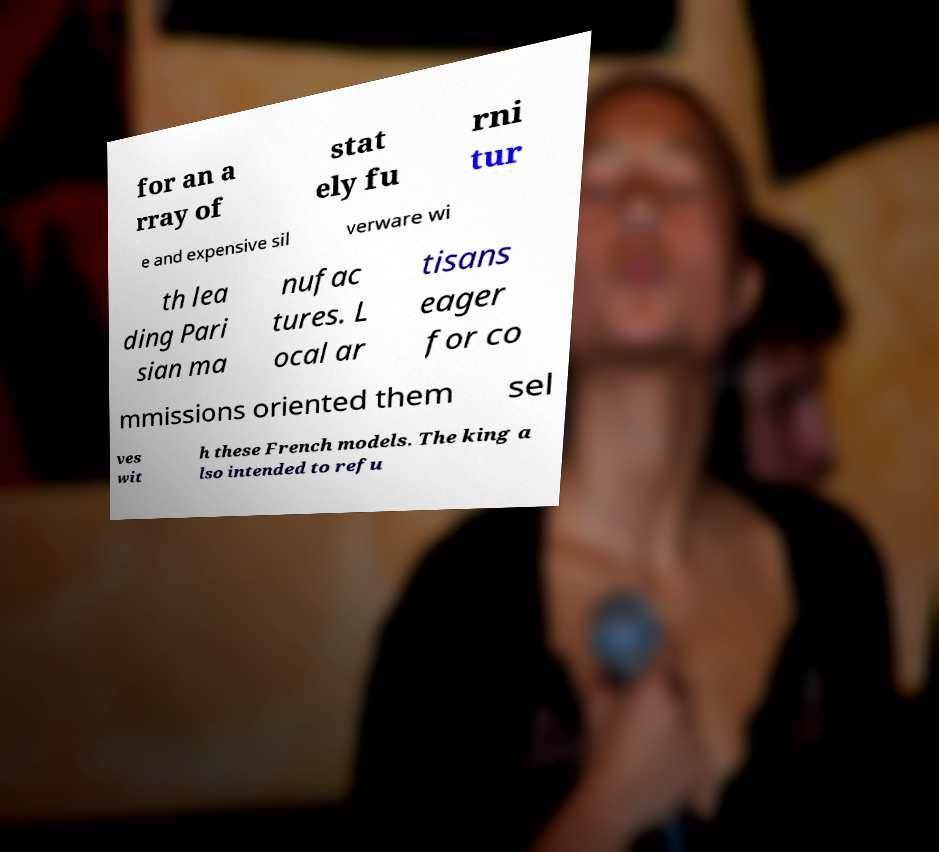Could you assist in decoding the text presented in this image and type it out clearly? for an a rray of stat ely fu rni tur e and expensive sil verware wi th lea ding Pari sian ma nufac tures. L ocal ar tisans eager for co mmissions oriented them sel ves wit h these French models. The king a lso intended to refu 